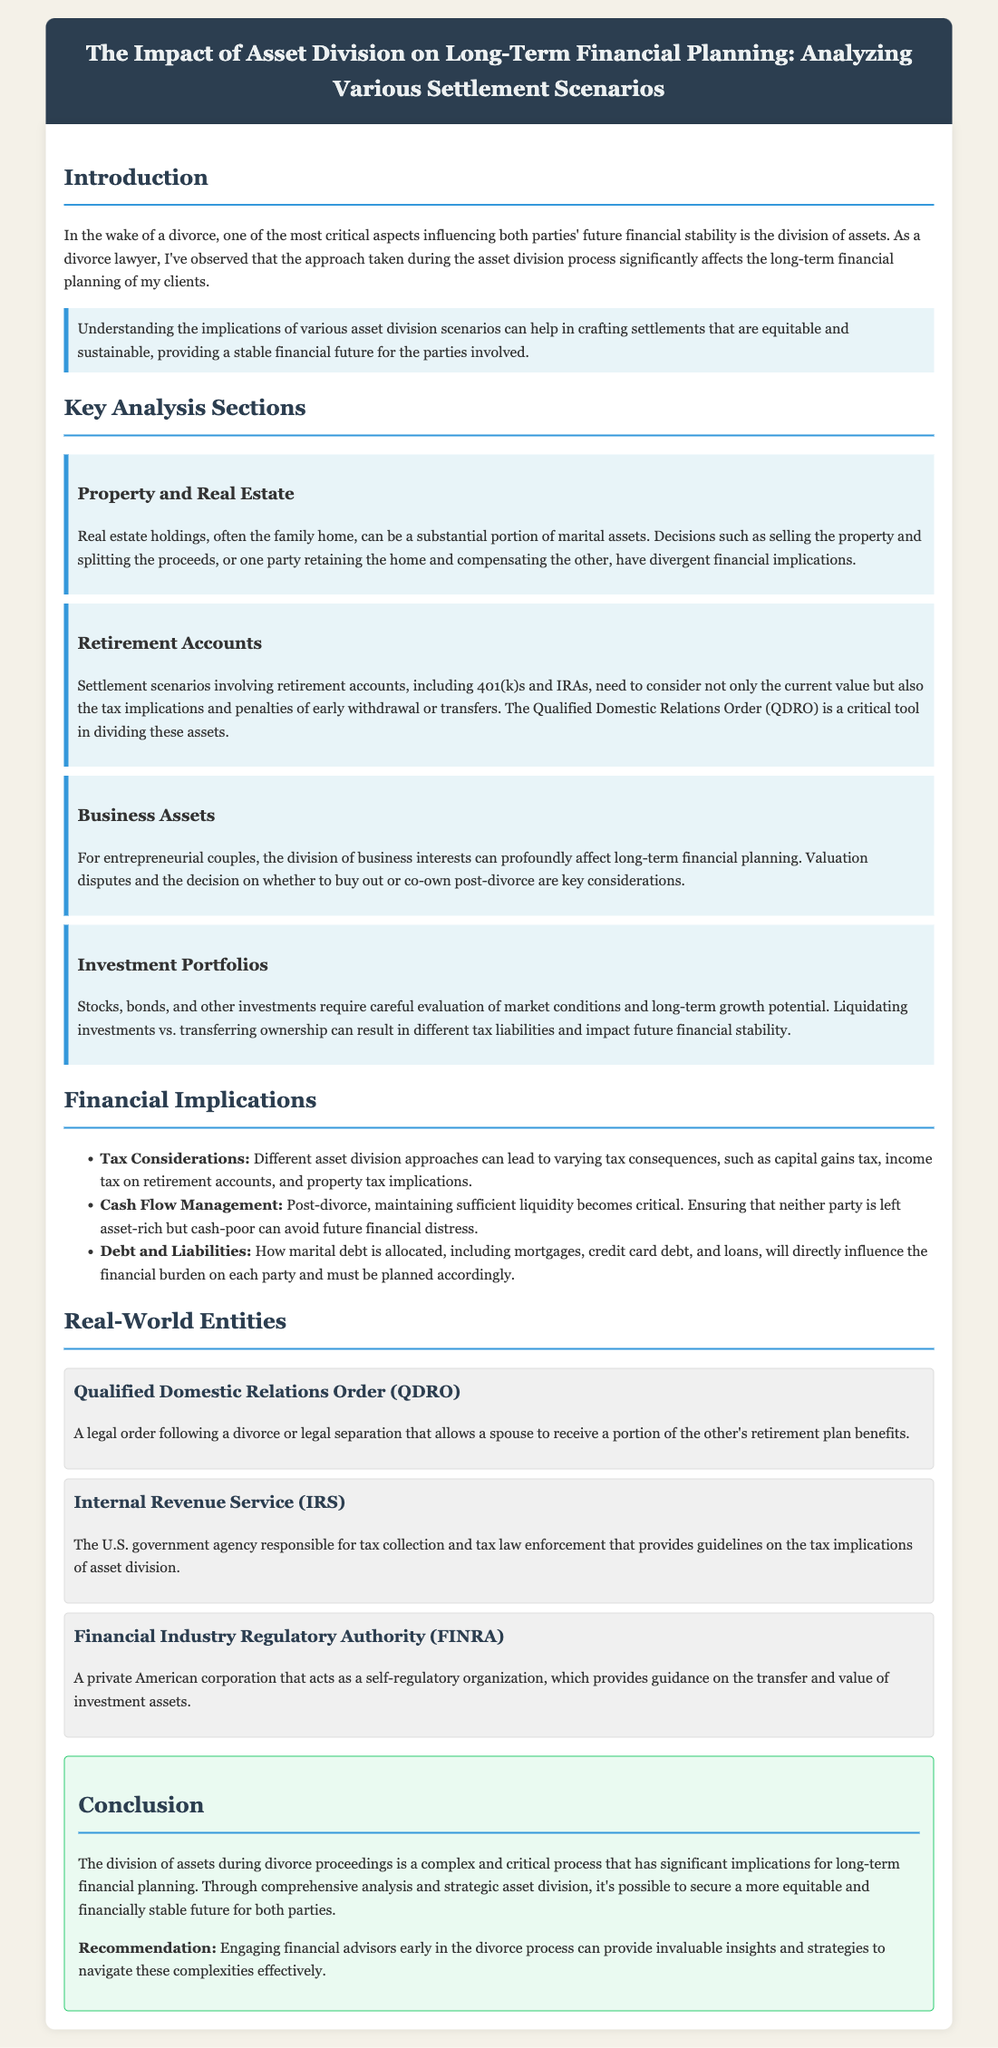what is the title of the document? The title of the document is presented in the header section of the legal brief.
Answer: The Impact of Asset Division on Long-Term Financial Planning: Analyzing Various Settlement Scenarios what is one key consideration for property and real estate? The section on Property and Real Estate discusses significant aspects related to decision-making during asset division.
Answer: Selling the property and splitting the proceeds what organization issues the Qualified Domestic Relations Order (QDRO)? The document explains what a QDRO is and identifies the entity responsible for its issuance.
Answer: A legal order what are retirement accounts that may be affected by asset division? The document mentions specific types of accounts that need consideration during settlement scenarios.
Answer: 401(k)s and IRAs what is a common issue related to business assets during divorce? In the section about Business Assets, the document highlights a major consideration when dividing business interests.
Answer: Valuation disputes how does the division of assets impact post-divorce cash flow? The financial implications section addresses how asset division can affect financial liquidity after divorce.
Answer: Maintaining sufficient liquidity what is the significance of the IRS in asset division? The document indicates the role of the IRS in relation to tax implications of asset division.
Answer: Tax collection and tax law enforcement what is a recommendation made in the conclusion? The conclusion provides a recommendation for individuals navigating asset division during divorce.
Answer: Engaging financial advisors early 